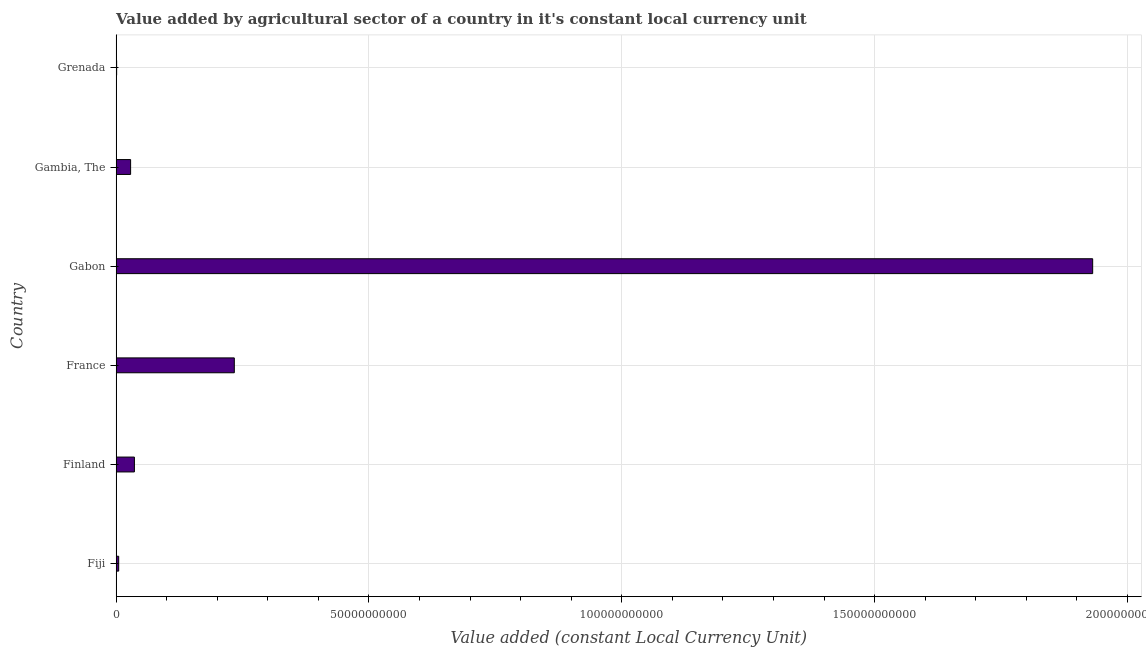Does the graph contain grids?
Your answer should be compact. Yes. What is the title of the graph?
Offer a terse response. Value added by agricultural sector of a country in it's constant local currency unit. What is the label or title of the X-axis?
Ensure brevity in your answer.  Value added (constant Local Currency Unit). What is the label or title of the Y-axis?
Offer a very short reply. Country. What is the value added by agriculture sector in Gambia, The?
Ensure brevity in your answer.  2.86e+09. Across all countries, what is the maximum value added by agriculture sector?
Your response must be concise. 1.93e+11. Across all countries, what is the minimum value added by agriculture sector?
Offer a very short reply. 1.01e+08. In which country was the value added by agriculture sector maximum?
Provide a short and direct response. Gabon. In which country was the value added by agriculture sector minimum?
Your response must be concise. Grenada. What is the sum of the value added by agriculture sector?
Your response must be concise. 2.24e+11. What is the difference between the value added by agriculture sector in Finland and Gambia, The?
Provide a succinct answer. 7.52e+08. What is the average value added by agriculture sector per country?
Keep it short and to the point. 3.73e+1. What is the median value added by agriculture sector?
Ensure brevity in your answer.  3.24e+09. What is the ratio of the value added by agriculture sector in France to that in Gabon?
Your answer should be very brief. 0.12. Is the value added by agriculture sector in Fiji less than that in Grenada?
Offer a terse response. No. Is the difference between the value added by agriculture sector in Fiji and France greater than the difference between any two countries?
Provide a short and direct response. No. What is the difference between the highest and the second highest value added by agriculture sector?
Offer a very short reply. 1.70e+11. What is the difference between the highest and the lowest value added by agriculture sector?
Ensure brevity in your answer.  1.93e+11. What is the Value added (constant Local Currency Unit) of Fiji?
Offer a very short reply. 5.05e+08. What is the Value added (constant Local Currency Unit) in Finland?
Give a very brief answer. 3.62e+09. What is the Value added (constant Local Currency Unit) in France?
Ensure brevity in your answer.  2.34e+1. What is the Value added (constant Local Currency Unit) of Gabon?
Ensure brevity in your answer.  1.93e+11. What is the Value added (constant Local Currency Unit) of Gambia, The?
Your response must be concise. 2.86e+09. What is the Value added (constant Local Currency Unit) in Grenada?
Provide a succinct answer. 1.01e+08. What is the difference between the Value added (constant Local Currency Unit) in Fiji and Finland?
Keep it short and to the point. -3.11e+09. What is the difference between the Value added (constant Local Currency Unit) in Fiji and France?
Make the answer very short. -2.29e+1. What is the difference between the Value added (constant Local Currency Unit) in Fiji and Gabon?
Offer a very short reply. -1.93e+11. What is the difference between the Value added (constant Local Currency Unit) in Fiji and Gambia, The?
Give a very brief answer. -2.36e+09. What is the difference between the Value added (constant Local Currency Unit) in Fiji and Grenada?
Ensure brevity in your answer.  4.05e+08. What is the difference between the Value added (constant Local Currency Unit) in Finland and France?
Ensure brevity in your answer.  -1.98e+1. What is the difference between the Value added (constant Local Currency Unit) in Finland and Gabon?
Offer a very short reply. -1.90e+11. What is the difference between the Value added (constant Local Currency Unit) in Finland and Gambia, The?
Provide a succinct answer. 7.52e+08. What is the difference between the Value added (constant Local Currency Unit) in Finland and Grenada?
Your answer should be compact. 3.51e+09. What is the difference between the Value added (constant Local Currency Unit) in France and Gabon?
Keep it short and to the point. -1.70e+11. What is the difference between the Value added (constant Local Currency Unit) in France and Gambia, The?
Offer a very short reply. 2.05e+1. What is the difference between the Value added (constant Local Currency Unit) in France and Grenada?
Give a very brief answer. 2.33e+1. What is the difference between the Value added (constant Local Currency Unit) in Gabon and Gambia, The?
Keep it short and to the point. 1.90e+11. What is the difference between the Value added (constant Local Currency Unit) in Gabon and Grenada?
Provide a short and direct response. 1.93e+11. What is the difference between the Value added (constant Local Currency Unit) in Gambia, The and Grenada?
Make the answer very short. 2.76e+09. What is the ratio of the Value added (constant Local Currency Unit) in Fiji to that in Finland?
Offer a terse response. 0.14. What is the ratio of the Value added (constant Local Currency Unit) in Fiji to that in France?
Make the answer very short. 0.02. What is the ratio of the Value added (constant Local Currency Unit) in Fiji to that in Gabon?
Your answer should be compact. 0. What is the ratio of the Value added (constant Local Currency Unit) in Fiji to that in Gambia, The?
Your response must be concise. 0.18. What is the ratio of the Value added (constant Local Currency Unit) in Fiji to that in Grenada?
Provide a short and direct response. 5.03. What is the ratio of the Value added (constant Local Currency Unit) in Finland to that in France?
Your answer should be compact. 0.15. What is the ratio of the Value added (constant Local Currency Unit) in Finland to that in Gabon?
Keep it short and to the point. 0.02. What is the ratio of the Value added (constant Local Currency Unit) in Finland to that in Gambia, The?
Offer a very short reply. 1.26. What is the ratio of the Value added (constant Local Currency Unit) in Finland to that in Grenada?
Your answer should be very brief. 35.95. What is the ratio of the Value added (constant Local Currency Unit) in France to that in Gabon?
Provide a succinct answer. 0.12. What is the ratio of the Value added (constant Local Currency Unit) in France to that in Gambia, The?
Your answer should be compact. 8.16. What is the ratio of the Value added (constant Local Currency Unit) in France to that in Grenada?
Provide a succinct answer. 232.44. What is the ratio of the Value added (constant Local Currency Unit) in Gabon to that in Gambia, The?
Your answer should be compact. 67.46. What is the ratio of the Value added (constant Local Currency Unit) in Gabon to that in Grenada?
Your answer should be compact. 1920.66. What is the ratio of the Value added (constant Local Currency Unit) in Gambia, The to that in Grenada?
Give a very brief answer. 28.47. 